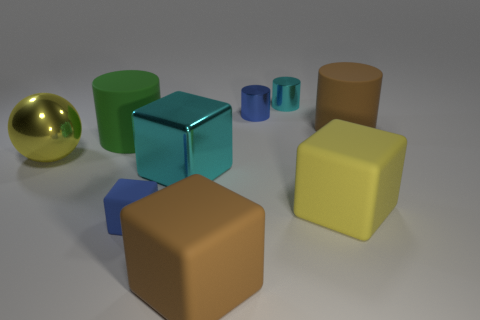Subtract all big brown rubber cubes. How many cubes are left? 3 Subtract 1 cylinders. How many cylinders are left? 3 Subtract all green cylinders. How many cylinders are left? 3 Subtract all red cubes. Subtract all yellow cylinders. How many cubes are left? 4 Add 1 cylinders. How many objects exist? 10 Subtract all blocks. How many objects are left? 5 Subtract all large brown cylinders. Subtract all yellow rubber things. How many objects are left? 7 Add 7 brown matte things. How many brown matte things are left? 9 Add 4 large metallic spheres. How many large metallic spheres exist? 5 Subtract 0 red cubes. How many objects are left? 9 